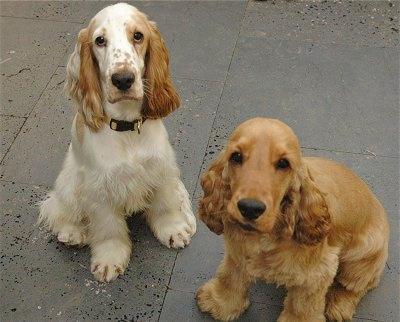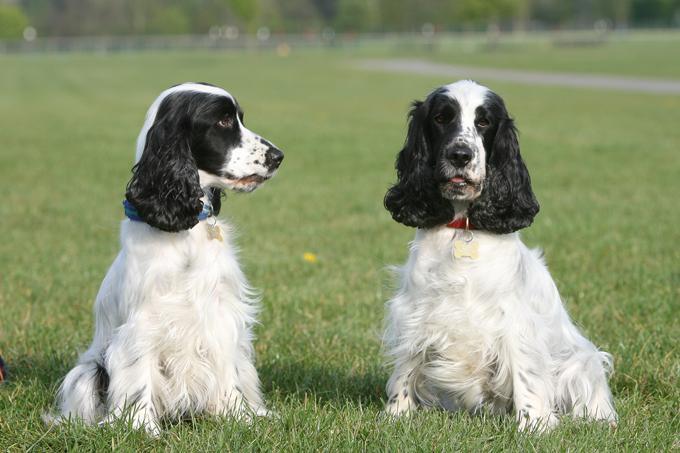The first image is the image on the left, the second image is the image on the right. Analyze the images presented: Is the assertion "An image includes at least three dogs of different colors." valid? Answer yes or no. No. The first image is the image on the left, the second image is the image on the right. Assess this claim about the two images: "At least two dogs are sitting int he grass.". Correct or not? Answer yes or no. Yes. The first image is the image on the left, the second image is the image on the right. For the images displayed, is the sentence "An image includes a white dog with black ears, and includes more than one dog." factually correct? Answer yes or no. Yes. The first image is the image on the left, the second image is the image on the right. Examine the images to the left and right. Is the description "The right image contains exactly two dogs." accurate? Answer yes or no. Yes. 